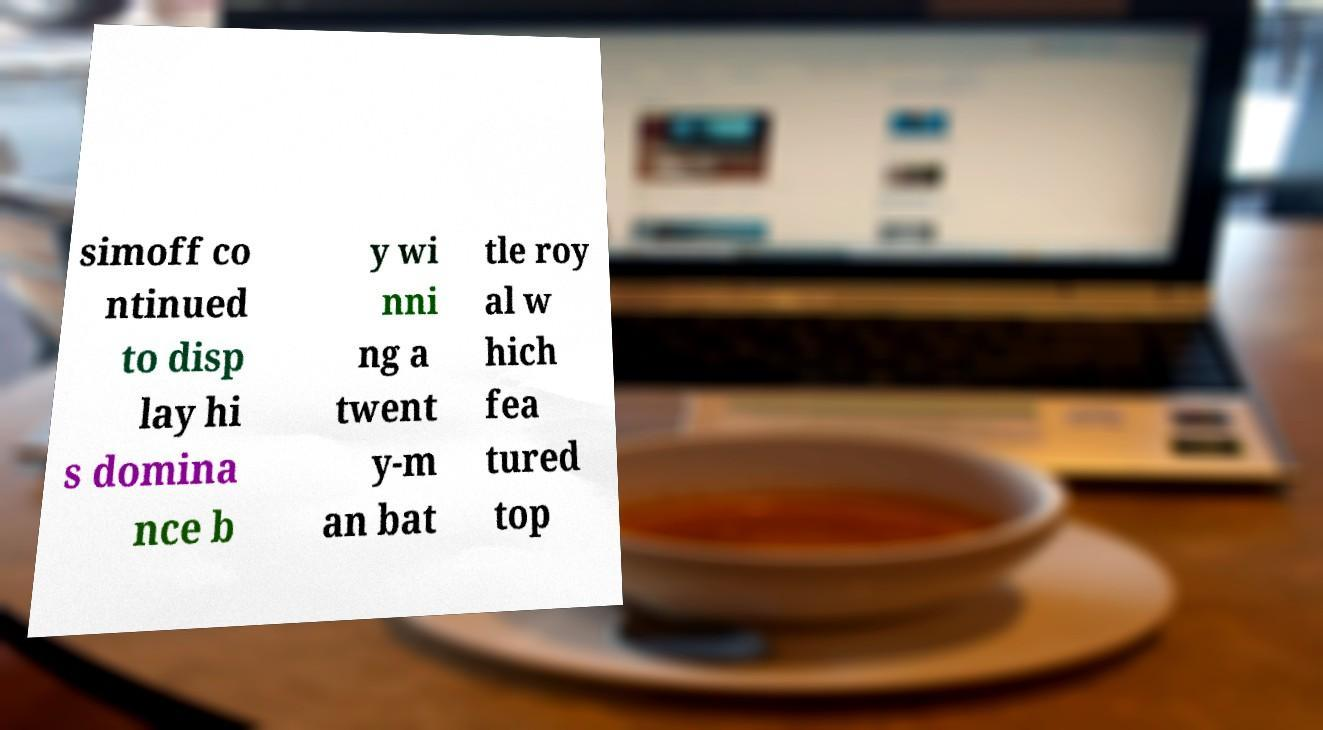Please read and relay the text visible in this image. What does it say? simoff co ntinued to disp lay hi s domina nce b y wi nni ng a twent y-m an bat tle roy al w hich fea tured top 